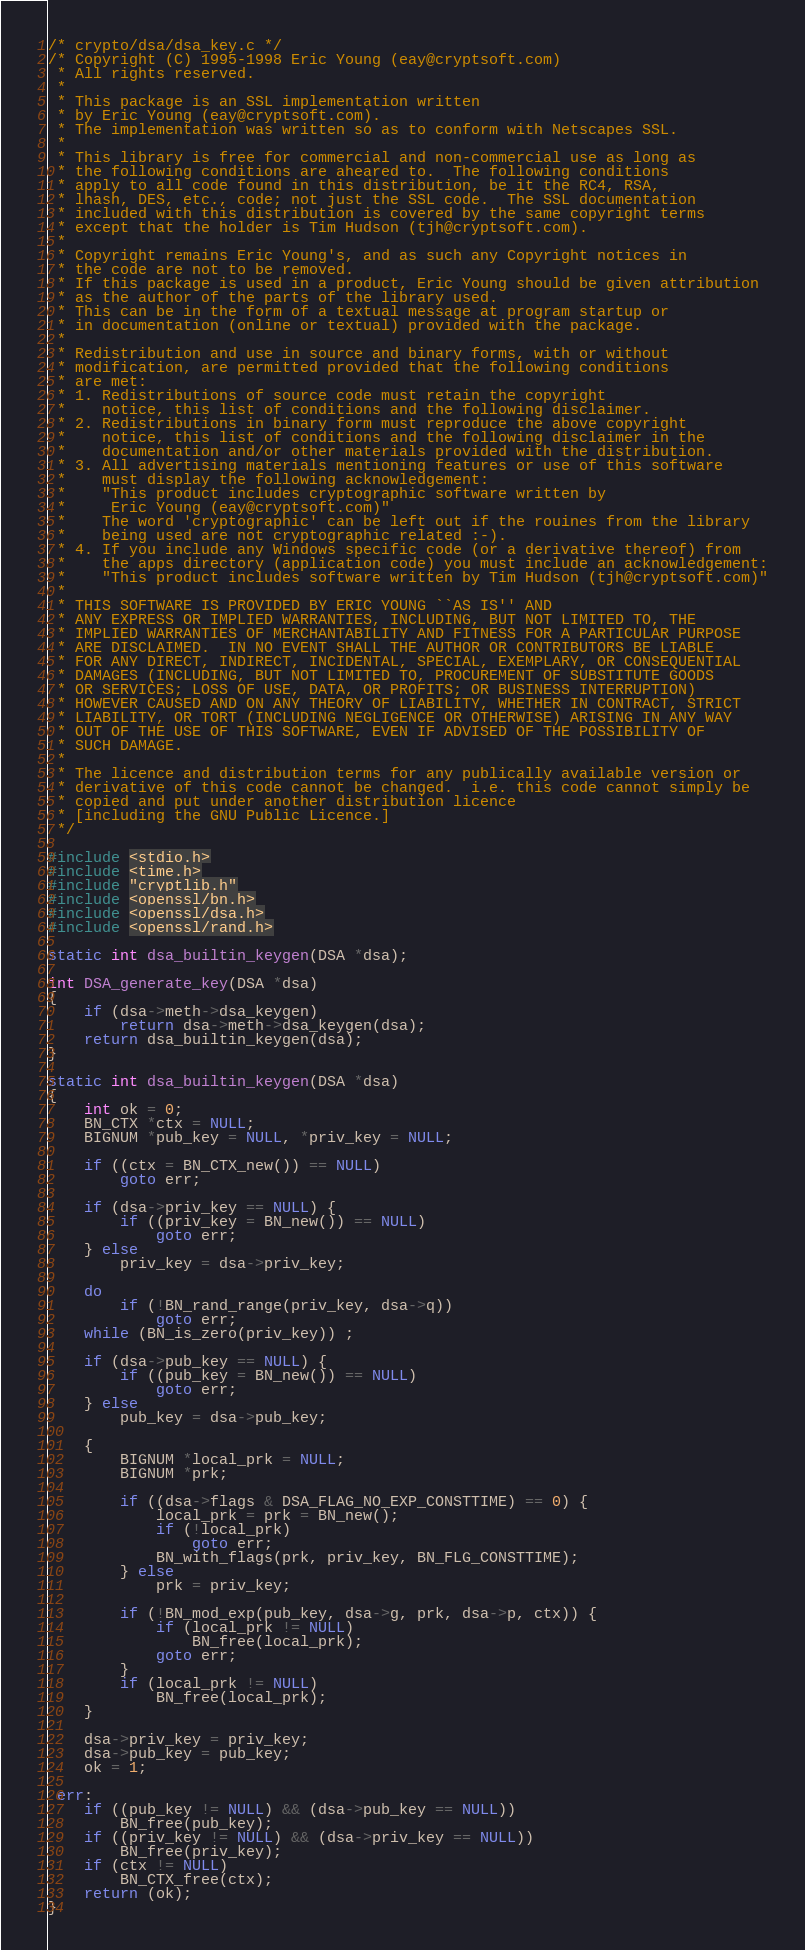Convert code to text. <code><loc_0><loc_0><loc_500><loc_500><_C_>/* crypto/dsa/dsa_key.c */
/* Copyright (C) 1995-1998 Eric Young (eay@cryptsoft.com)
 * All rights reserved.
 *
 * This package is an SSL implementation written
 * by Eric Young (eay@cryptsoft.com).
 * The implementation was written so as to conform with Netscapes SSL.
 *
 * This library is free for commercial and non-commercial use as long as
 * the following conditions are aheared to.  The following conditions
 * apply to all code found in this distribution, be it the RC4, RSA,
 * lhash, DES, etc., code; not just the SSL code.  The SSL documentation
 * included with this distribution is covered by the same copyright terms
 * except that the holder is Tim Hudson (tjh@cryptsoft.com).
 *
 * Copyright remains Eric Young's, and as such any Copyright notices in
 * the code are not to be removed.
 * If this package is used in a product, Eric Young should be given attribution
 * as the author of the parts of the library used.
 * This can be in the form of a textual message at program startup or
 * in documentation (online or textual) provided with the package.
 *
 * Redistribution and use in source and binary forms, with or without
 * modification, are permitted provided that the following conditions
 * are met:
 * 1. Redistributions of source code must retain the copyright
 *    notice, this list of conditions and the following disclaimer.
 * 2. Redistributions in binary form must reproduce the above copyright
 *    notice, this list of conditions and the following disclaimer in the
 *    documentation and/or other materials provided with the distribution.
 * 3. All advertising materials mentioning features or use of this software
 *    must display the following acknowledgement:
 *    "This product includes cryptographic software written by
 *     Eric Young (eay@cryptsoft.com)"
 *    The word 'cryptographic' can be left out if the rouines from the library
 *    being used are not cryptographic related :-).
 * 4. If you include any Windows specific code (or a derivative thereof) from
 *    the apps directory (application code) you must include an acknowledgement:
 *    "This product includes software written by Tim Hudson (tjh@cryptsoft.com)"
 *
 * THIS SOFTWARE IS PROVIDED BY ERIC YOUNG ``AS IS'' AND
 * ANY EXPRESS OR IMPLIED WARRANTIES, INCLUDING, BUT NOT LIMITED TO, THE
 * IMPLIED WARRANTIES OF MERCHANTABILITY AND FITNESS FOR A PARTICULAR PURPOSE
 * ARE DISCLAIMED.  IN NO EVENT SHALL THE AUTHOR OR CONTRIBUTORS BE LIABLE
 * FOR ANY DIRECT, INDIRECT, INCIDENTAL, SPECIAL, EXEMPLARY, OR CONSEQUENTIAL
 * DAMAGES (INCLUDING, BUT NOT LIMITED TO, PROCUREMENT OF SUBSTITUTE GOODS
 * OR SERVICES; LOSS OF USE, DATA, OR PROFITS; OR BUSINESS INTERRUPTION)
 * HOWEVER CAUSED AND ON ANY THEORY OF LIABILITY, WHETHER IN CONTRACT, STRICT
 * LIABILITY, OR TORT (INCLUDING NEGLIGENCE OR OTHERWISE) ARISING IN ANY WAY
 * OUT OF THE USE OF THIS SOFTWARE, EVEN IF ADVISED OF THE POSSIBILITY OF
 * SUCH DAMAGE.
 *
 * The licence and distribution terms for any publically available version or
 * derivative of this code cannot be changed.  i.e. this code cannot simply be
 * copied and put under another distribution licence
 * [including the GNU Public Licence.]
 */

#include <stdio.h>
#include <time.h>
#include "cryptlib.h"
#include <openssl/bn.h>
#include <openssl/dsa.h>
#include <openssl/rand.h>

static int dsa_builtin_keygen(DSA *dsa);

int DSA_generate_key(DSA *dsa)
{
    if (dsa->meth->dsa_keygen)
        return dsa->meth->dsa_keygen(dsa);
    return dsa_builtin_keygen(dsa);
}

static int dsa_builtin_keygen(DSA *dsa)
{
    int ok = 0;
    BN_CTX *ctx = NULL;
    BIGNUM *pub_key = NULL, *priv_key = NULL;

    if ((ctx = BN_CTX_new()) == NULL)
        goto err;

    if (dsa->priv_key == NULL) {
        if ((priv_key = BN_new()) == NULL)
            goto err;
    } else
        priv_key = dsa->priv_key;

    do
        if (!BN_rand_range(priv_key, dsa->q))
            goto err;
    while (BN_is_zero(priv_key)) ;

    if (dsa->pub_key == NULL) {
        if ((pub_key = BN_new()) == NULL)
            goto err;
    } else
        pub_key = dsa->pub_key;

    {
        BIGNUM *local_prk = NULL;
        BIGNUM *prk;

        if ((dsa->flags & DSA_FLAG_NO_EXP_CONSTTIME) == 0) {
            local_prk = prk = BN_new();
            if (!local_prk)
                goto err;
            BN_with_flags(prk, priv_key, BN_FLG_CONSTTIME);
        } else
            prk = priv_key;

        if (!BN_mod_exp(pub_key, dsa->g, prk, dsa->p, ctx)) {
            if (local_prk != NULL)
                BN_free(local_prk);
            goto err;
        }
        if (local_prk != NULL)
            BN_free(local_prk);
    }

    dsa->priv_key = priv_key;
    dsa->pub_key = pub_key;
    ok = 1;

 err:
    if ((pub_key != NULL) && (dsa->pub_key == NULL))
        BN_free(pub_key);
    if ((priv_key != NULL) && (dsa->priv_key == NULL))
        BN_free(priv_key);
    if (ctx != NULL)
        BN_CTX_free(ctx);
    return (ok);
}
</code> 